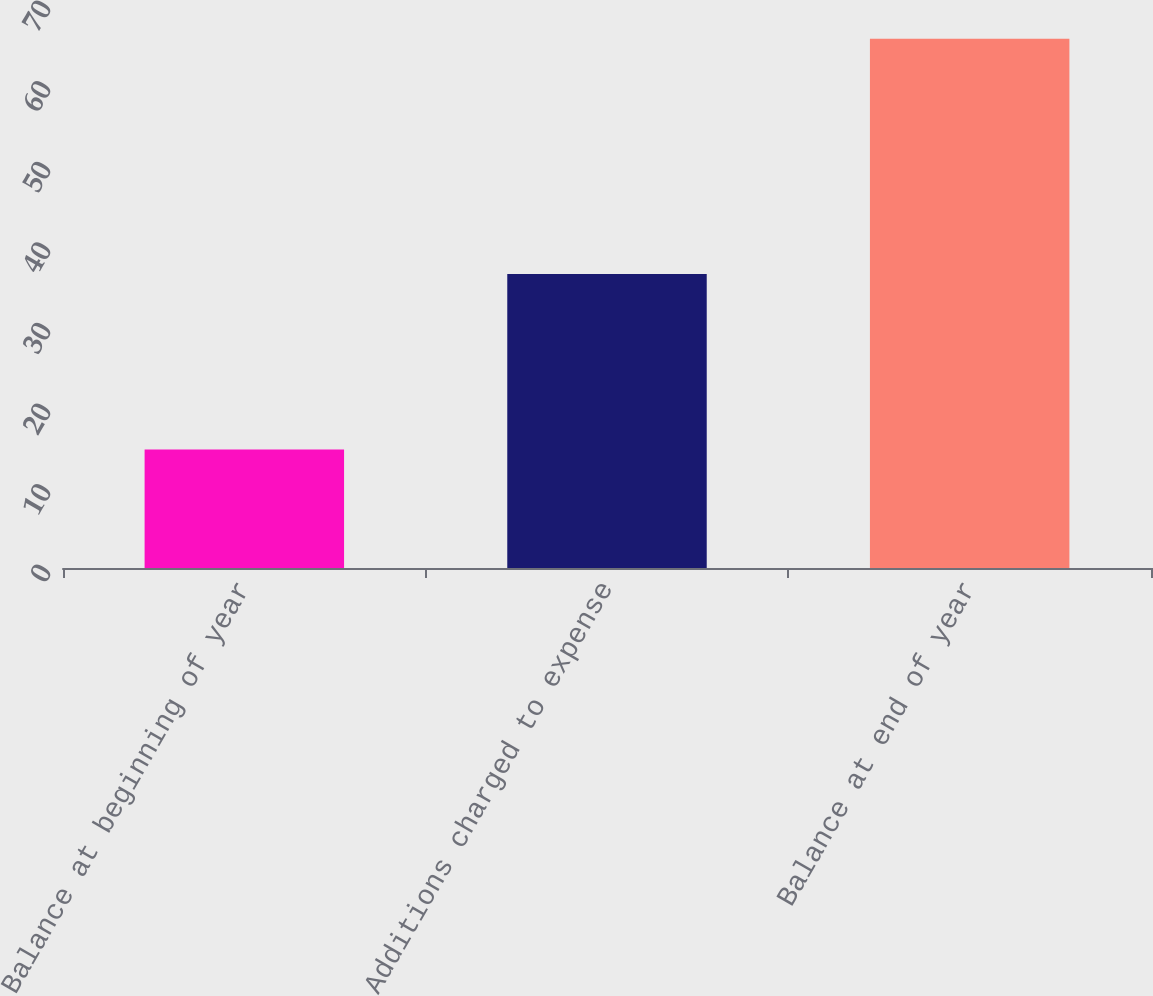Convert chart. <chart><loc_0><loc_0><loc_500><loc_500><bar_chart><fcel>Balance at beginning of year<fcel>Additions charged to expense<fcel>Balance at end of year<nl><fcel>14.7<fcel>36.5<fcel>65.7<nl></chart> 